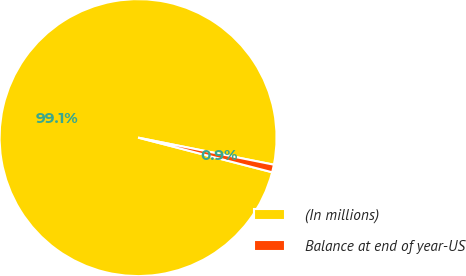Convert chart to OTSL. <chart><loc_0><loc_0><loc_500><loc_500><pie_chart><fcel>(In millions)<fcel>Balance at end of year-US<nl><fcel>99.11%<fcel>0.89%<nl></chart> 